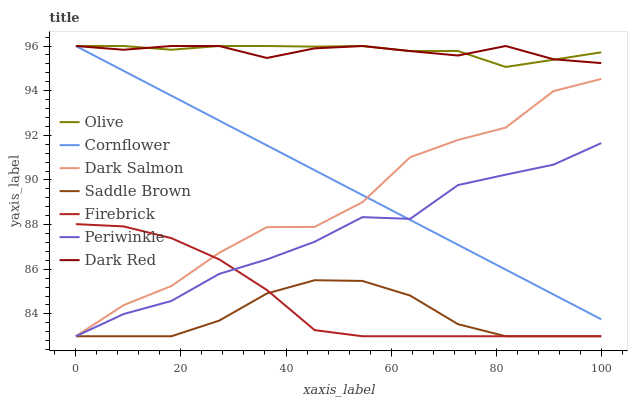Does Saddle Brown have the minimum area under the curve?
Answer yes or no. Yes. Does Olive have the maximum area under the curve?
Answer yes or no. Yes. Does Dark Red have the minimum area under the curve?
Answer yes or no. No. Does Dark Red have the maximum area under the curve?
Answer yes or no. No. Is Cornflower the smoothest?
Answer yes or no. Yes. Is Dark Salmon the roughest?
Answer yes or no. Yes. Is Dark Red the smoothest?
Answer yes or no. No. Is Dark Red the roughest?
Answer yes or no. No. Does Firebrick have the lowest value?
Answer yes or no. Yes. Does Dark Red have the lowest value?
Answer yes or no. No. Does Olive have the highest value?
Answer yes or no. Yes. Does Firebrick have the highest value?
Answer yes or no. No. Is Firebrick less than Olive?
Answer yes or no. Yes. Is Cornflower greater than Firebrick?
Answer yes or no. Yes. Does Dark Salmon intersect Firebrick?
Answer yes or no. Yes. Is Dark Salmon less than Firebrick?
Answer yes or no. No. Is Dark Salmon greater than Firebrick?
Answer yes or no. No. Does Firebrick intersect Olive?
Answer yes or no. No. 